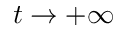<formula> <loc_0><loc_0><loc_500><loc_500>t \to + \infty</formula> 